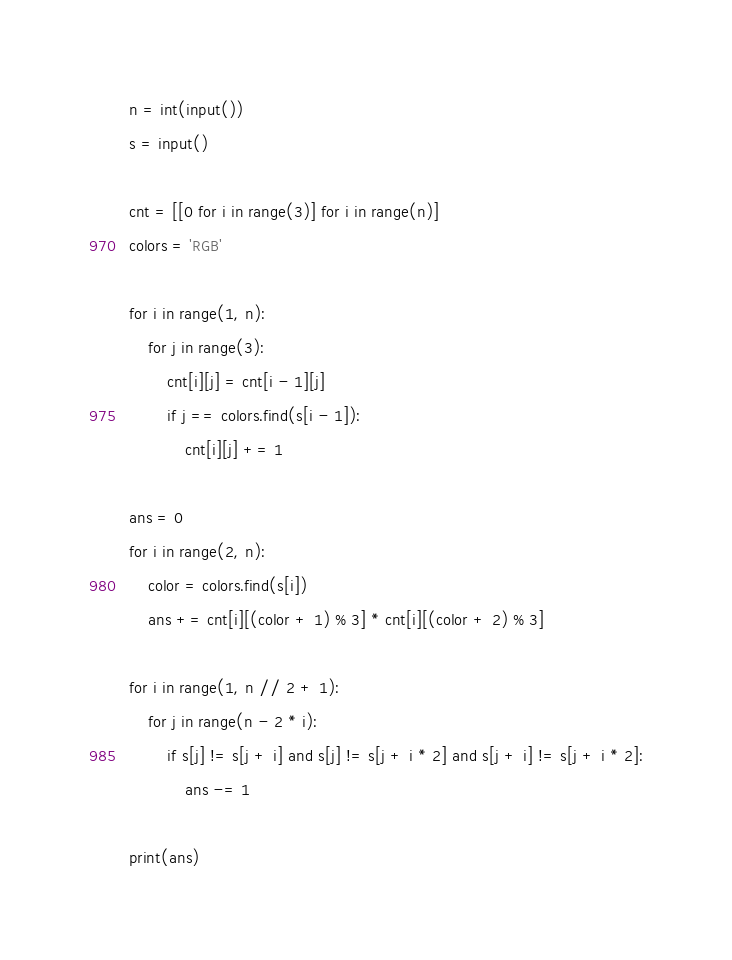<code> <loc_0><loc_0><loc_500><loc_500><_Python_>n = int(input())
s = input()

cnt = [[0 for i in range(3)] for i in range(n)]
colors = 'RGB'

for i in range(1, n):
    for j in range(3):
        cnt[i][j] = cnt[i - 1][j]
        if j == colors.find(s[i - 1]):
            cnt[i][j] += 1

ans = 0
for i in range(2, n):
    color = colors.find(s[i])
    ans += cnt[i][(color + 1) % 3] * cnt[i][(color + 2) % 3]

for i in range(1, n // 2 + 1):
    for j in range(n - 2 * i):
        if s[j] != s[j + i] and s[j] != s[j + i * 2] and s[j + i] != s[j + i * 2]:
            ans -= 1

print(ans)</code> 